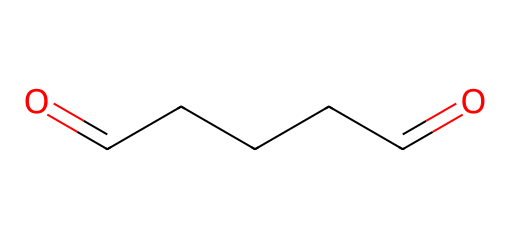What is the name of this chemical? The SMILES representation indicates this chemical has two carbonyl groups at the ends of a five-carbon chain, which characterizes it as glutaraldehyde.
Answer: glutaraldehyde How many carbon atoms are in glutaraldehyde? The structure shows a straight-chain with five carbon atoms, confirmed by counting the 'C' in the SMILES representation.
Answer: five What functional groups are present in glutaraldehyde? The presence of two carbonyl groups (C=O) at both ends of the carbon chain indicates the presence of aldehyde functional groups.
Answer: aldehyde What is the total number of hydrogen atoms in glutaraldehyde? Each carbon in the carbon chain can bond with enough hydrogens to satisfy its tetravalency, leading to a total of 8 hydrogen atoms when considering the terminal carbonyl groups.
Answer: eight Why is glutaraldehyde considered an aldehyde? Glutaraldehyde possesses the defining characteristic of aldehydes: a carbonyl group at one end of the carbon chain, which meets the general definition of aldehydes.
Answer: carbonyl group 